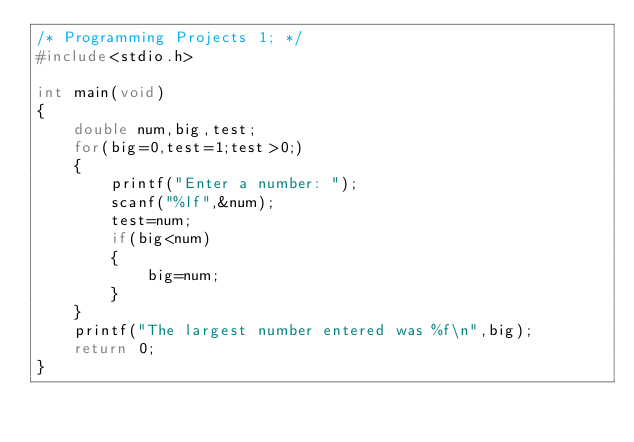Convert code to text. <code><loc_0><loc_0><loc_500><loc_500><_C_>/* Programming Projects 1; */
#include<stdio.h>

int main(void)
{
    double num,big,test;
    for(big=0,test=1;test>0;)
    {
        printf("Enter a number: ");
        scanf("%lf",&num);
        test=num;
        if(big<num)
        {
            big=num;
        }
    }
    printf("The largest number entered was %f\n",big);
    return 0;
}
</code> 